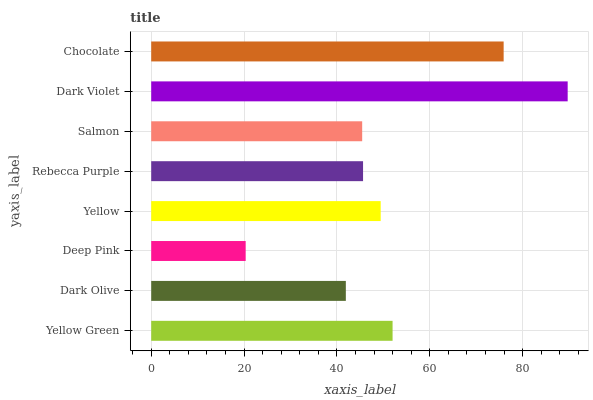Is Deep Pink the minimum?
Answer yes or no. Yes. Is Dark Violet the maximum?
Answer yes or no. Yes. Is Dark Olive the minimum?
Answer yes or no. No. Is Dark Olive the maximum?
Answer yes or no. No. Is Yellow Green greater than Dark Olive?
Answer yes or no. Yes. Is Dark Olive less than Yellow Green?
Answer yes or no. Yes. Is Dark Olive greater than Yellow Green?
Answer yes or no. No. Is Yellow Green less than Dark Olive?
Answer yes or no. No. Is Yellow the high median?
Answer yes or no. Yes. Is Rebecca Purple the low median?
Answer yes or no. Yes. Is Dark Olive the high median?
Answer yes or no. No. Is Salmon the low median?
Answer yes or no. No. 